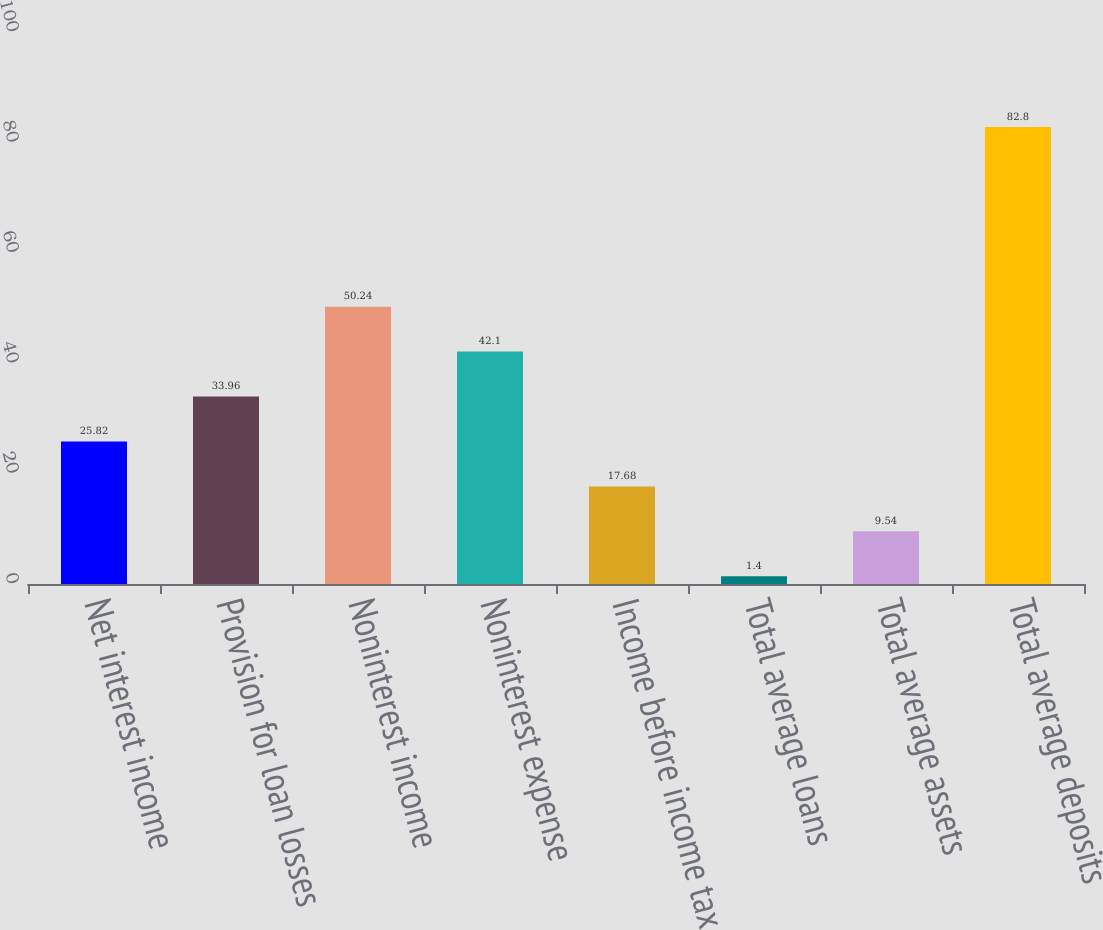Convert chart to OTSL. <chart><loc_0><loc_0><loc_500><loc_500><bar_chart><fcel>Net interest income<fcel>Provision for loan losses<fcel>Noninterest income<fcel>Noninterest expense<fcel>Income before income tax<fcel>Total average loans<fcel>Total average assets<fcel>Total average deposits<nl><fcel>25.82<fcel>33.96<fcel>50.24<fcel>42.1<fcel>17.68<fcel>1.4<fcel>9.54<fcel>82.8<nl></chart> 